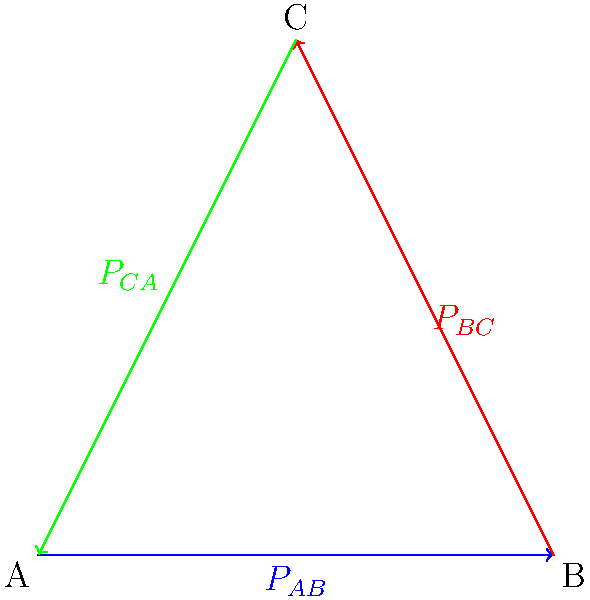In the power grid network shown, transmission lines connect nodes A, B, and C. The power flows are represented by $P_{AB}$, $P_{BC}$, and $P_{CA}$. If the magnitude of power flow in each line is 100 MW, and the angles between the power flow vectors are 120°, calculate the net power injection at node B using vector analysis. To solve this problem, we'll use vector analysis:

1) First, let's define our vectors in complex plane notation:
   $\vec{P_{AB}} = 100 \angle 0° = 100 + 0i$ MW
   $\vec{P_{BC}} = 100 \angle 120° = -50 + 86.6i$ MW
   $\vec{P_{CA}} = 100 \angle 240° = -50 - 86.6i$ MW

2) The net power injection at node B is the sum of power flowing into B minus the power flowing out of B:
   $P_{B,net} = \vec{P_{AB}} - \vec{P_{BC}}$

3) Substituting our values:
   $P_{B,net} = (100 + 0i) - (-50 + 86.6i)$

4) Simplifying:
   $P_{B,net} = 150 - 86.6i$ MW

5) To get the magnitude of this net power:
   $|P_{B,net}| = \sqrt{150^2 + (-86.6)^2} = 173.2$ MW

6) To get the angle:
   $\theta = \tan^{-1}(-86.6/150) = -30°$

Therefore, the net power injection at node B is 173.2 MW at an angle of -30°.
Answer: 173.2 MW ∠ -30° 